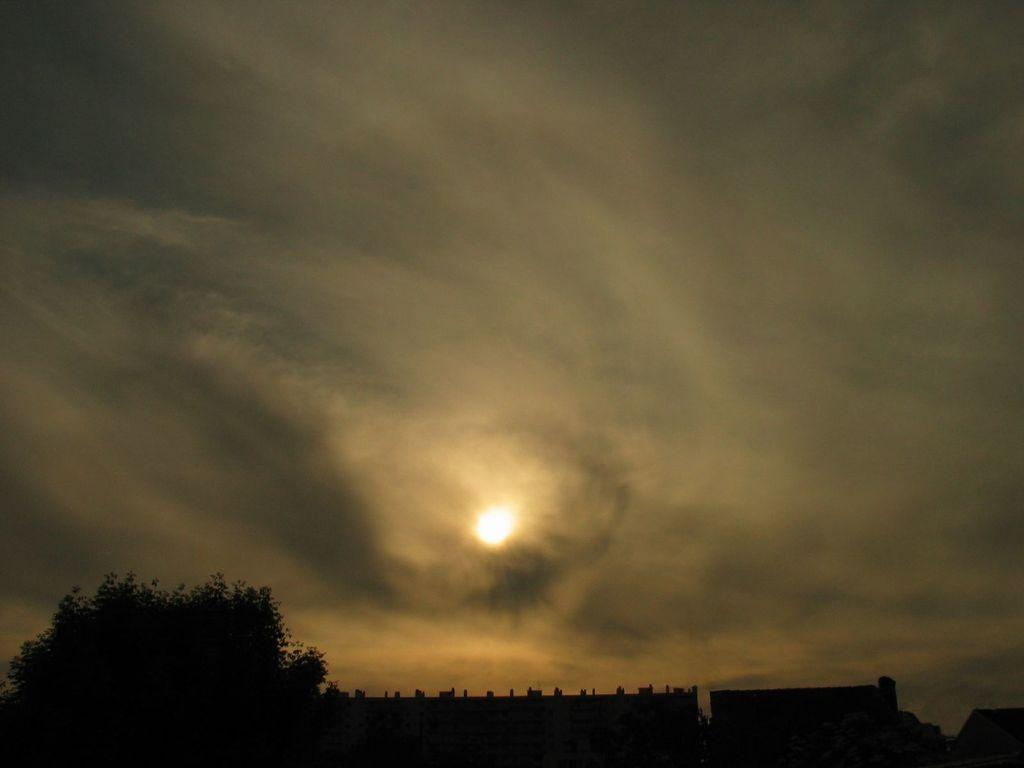What celestial body can be seen in the sky in the image? The sun is visible in the sky in the image. What else is present in the sky in the image? There are clouds in the sky in the image. What is located at the bottom of the image? There is a tree and buildings in the bottom of the image. How many bikes are parked near the tree in the image? There are no bikes present in the image. What type of angle is the tree leaning at in the image? The tree is not leaning in the image; it is standing upright. 